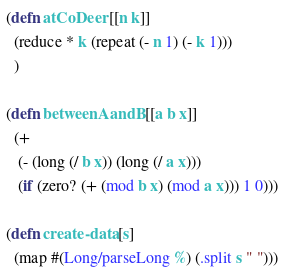<code> <loc_0><loc_0><loc_500><loc_500><_Clojure_>(defn atCoDeer [[n k]]
  (reduce * k (repeat (- n 1) (- k 1)))
  )

(defn betweenAandB [[a b x]]
  (+ 
   (- (long (/ b x)) (long (/ a x)))
   (if (zero? (+ (mod b x) (mod a x))) 1 0)))

(defn create-data [s]
  (map #(Long/parseLong %) (.split s " ")))</code> 